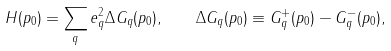Convert formula to latex. <formula><loc_0><loc_0><loc_500><loc_500>H ( p _ { 0 } ) = \sum _ { q } e _ { q } ^ { 2 } \Delta G _ { q } ( p _ { 0 } ) , \quad \Delta G _ { q } ( p _ { 0 } ) \equiv G _ { q } ^ { + } ( p _ { 0 } ) - G _ { q } ^ { - } ( p _ { 0 } ) ,</formula> 